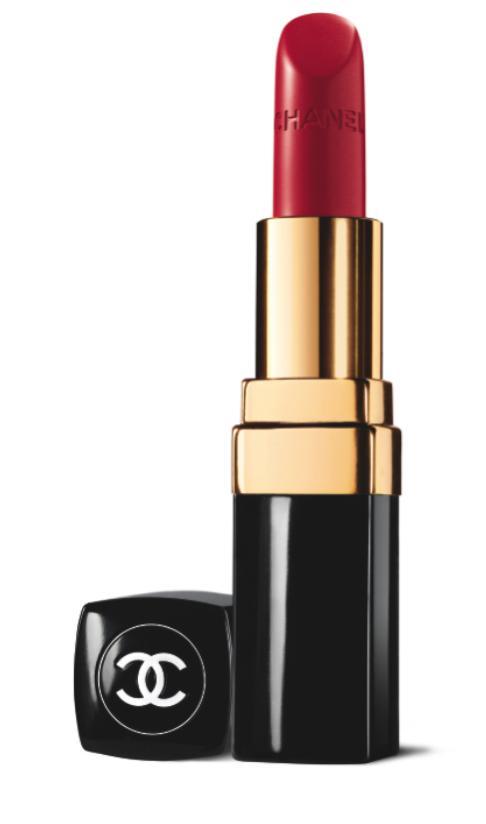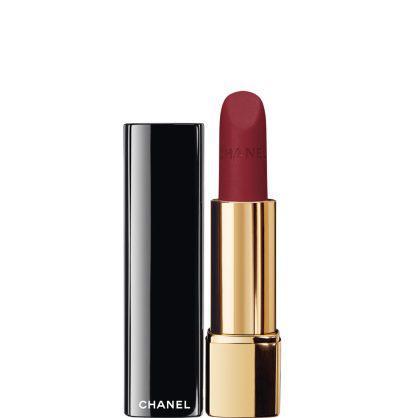The first image is the image on the left, the second image is the image on the right. Given the left and right images, does the statement "One images shows at least five tubes of lipstick with all the caps off lined up in a row." hold true? Answer yes or no. No. The first image is the image on the left, the second image is the image on the right. Analyze the images presented: Is the assertion "One image shows a single red upright lipstick next to its upright cover." valid? Answer yes or no. Yes. 